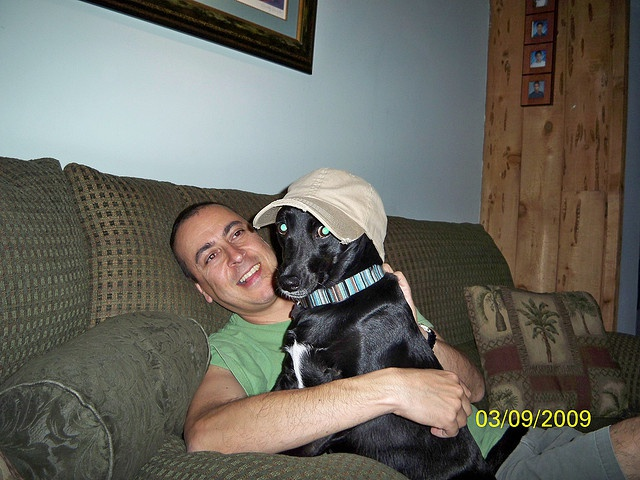Describe the objects in this image and their specific colors. I can see couch in gray and black tones, dog in gray, black, darkgray, and lightgray tones, people in gray and tan tones, and clock in gray, white, darkgray, and black tones in this image. 